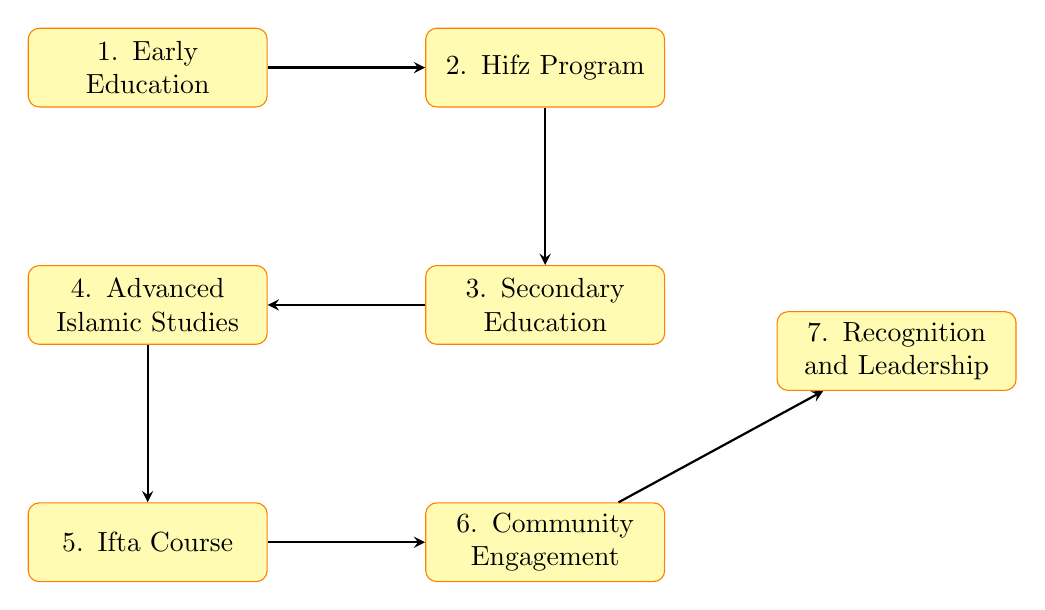What's the first step in becoming a renowned Islamic scholar in Bangladesh? The diagram indicates that the first step is "Early Education," which focuses on primary education with an emphasis on the Quran and basic Islamic principles under local madrassas.
Answer: Early Education How many nodes are present in the diagram? The diagram lists a total of 7 distinct nodes related to the steps in the process, from Early Education to Recognition and Leadership.
Answer: 7 What is the last step of the process outlined in the diagram? The final step in the flow chart is "Recognition and Leadership," which signifies the achievement of recognition through scholarly contributions.
Answer: Recognition and Leadership Which step comes after the Hifz Program? According to the flow chart, the step that follows the Hifz Program is "Secondary Education," emphasizing the continuation of education alongside Islamic studies.
Answer: Secondary Education What type of course is needed to become a certified Mufti? The diagram specifies the completion of an "Ifta Course" as the necessary step to certify an individual as a Mufti, enabling them to issue Islamic legal opinions.
Answer: Ifta Course Explain the progression from Secondary Education to Community Engagement. The diagram illustrates a sequential flow where after completing Secondary Education, the next step is "Advanced Islamic Studies." Once this step is achieved, the individual then moves on to "Community Engagement," which involves active participation and contribution to the community through workshops and writings.
Answer: Advanced Islamic Studies What is the relationship between Advanced Islamic Studies and Ifta Course? The flow chart shows that the Ifta Course follows Advanced Islamic Studies. This means that after completing advanced studies, one must enroll in an Ifta Course to progress further in the process.
Answer: next How does community engagement contribute to becoming a renowned scholar? According to the diagram, community engagement is a critical step that follows the Ifta Course. This engagement allows the scholar to build recognition through workshops and participation in Dawah activities, ultimately leading to "Recognition and Leadership."
Answer: Recognition through engagement 